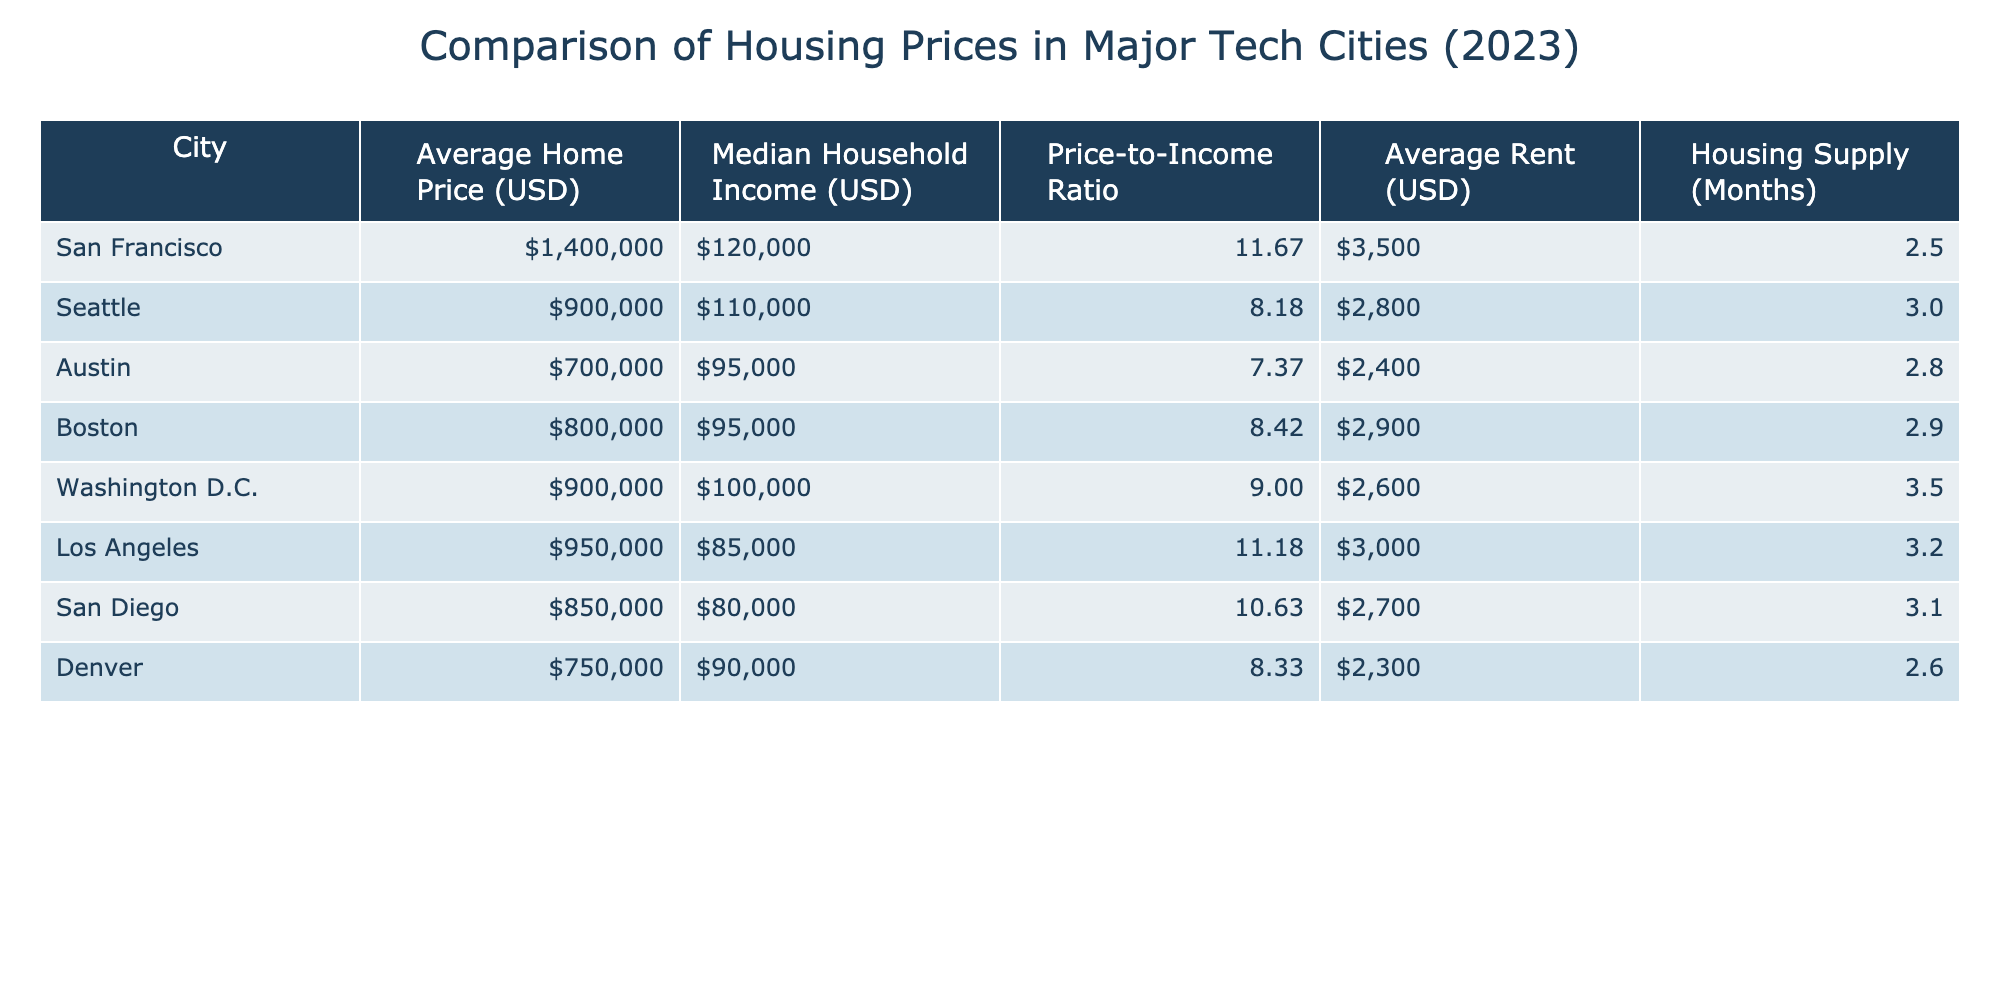What's the average home price in Austin? The table lists Austin's average home price as 700,000 USD.
Answer: 700000 Which city has the highest price-to-income ratio? Reviewing the table, San Francisco has the highest price-to-income ratio at 11.67.
Answer: San Francisco Is the median household income in Seattle greater than that in San Diego? The table shows Seattle's median household income at 110,000 USD and San Diego's at 80,000 USD, indicating that Seattle's income is indeed greater.
Answer: Yes What is the average rent in Boston compared to Denver? The table shows that Boston's average rent is 2900 USD and Denver's is 2300 USD. Since 2900 is greater than 2300, Boston's rent is higher.
Answer: Higher Calculate the difference in average home price between San Francisco and Washington D.C. San Francisco's average home price is 1,400,000 USD and Washington D.C.'s is 900,000 USD. The difference is calculated as 1,400,000 - 900,000 = 500,000 USD.
Answer: 500000 Are there more months of housing supply in San Diego than in Austin? The table indicates that San Diego has 3.1 months of housing supply while Austin has 2.8 months. Thus, San Diego indeed has more supply.
Answer: Yes What's the total median household income of all the cities listed? The median household incomes from the table add up as follows: 120000 + 110000 + 95000 + 95000 + 100000 + 85000 + 80000 + 90000 =  1,060,000 USD.
Answer: 1060000 Which city has the lowest average rent? From the table, Denver shows the lowest average rent at 2300 USD, compared to other cities.
Answer: Denver If you want to compare the average home price to median household income, which city offers the lowest price-to-income ratio? The price-to-income ratios show that Austin has the lowest ratio at 7.37, compared to the others. This means that its home prices are more affordable relative to its income.
Answer: Austin 